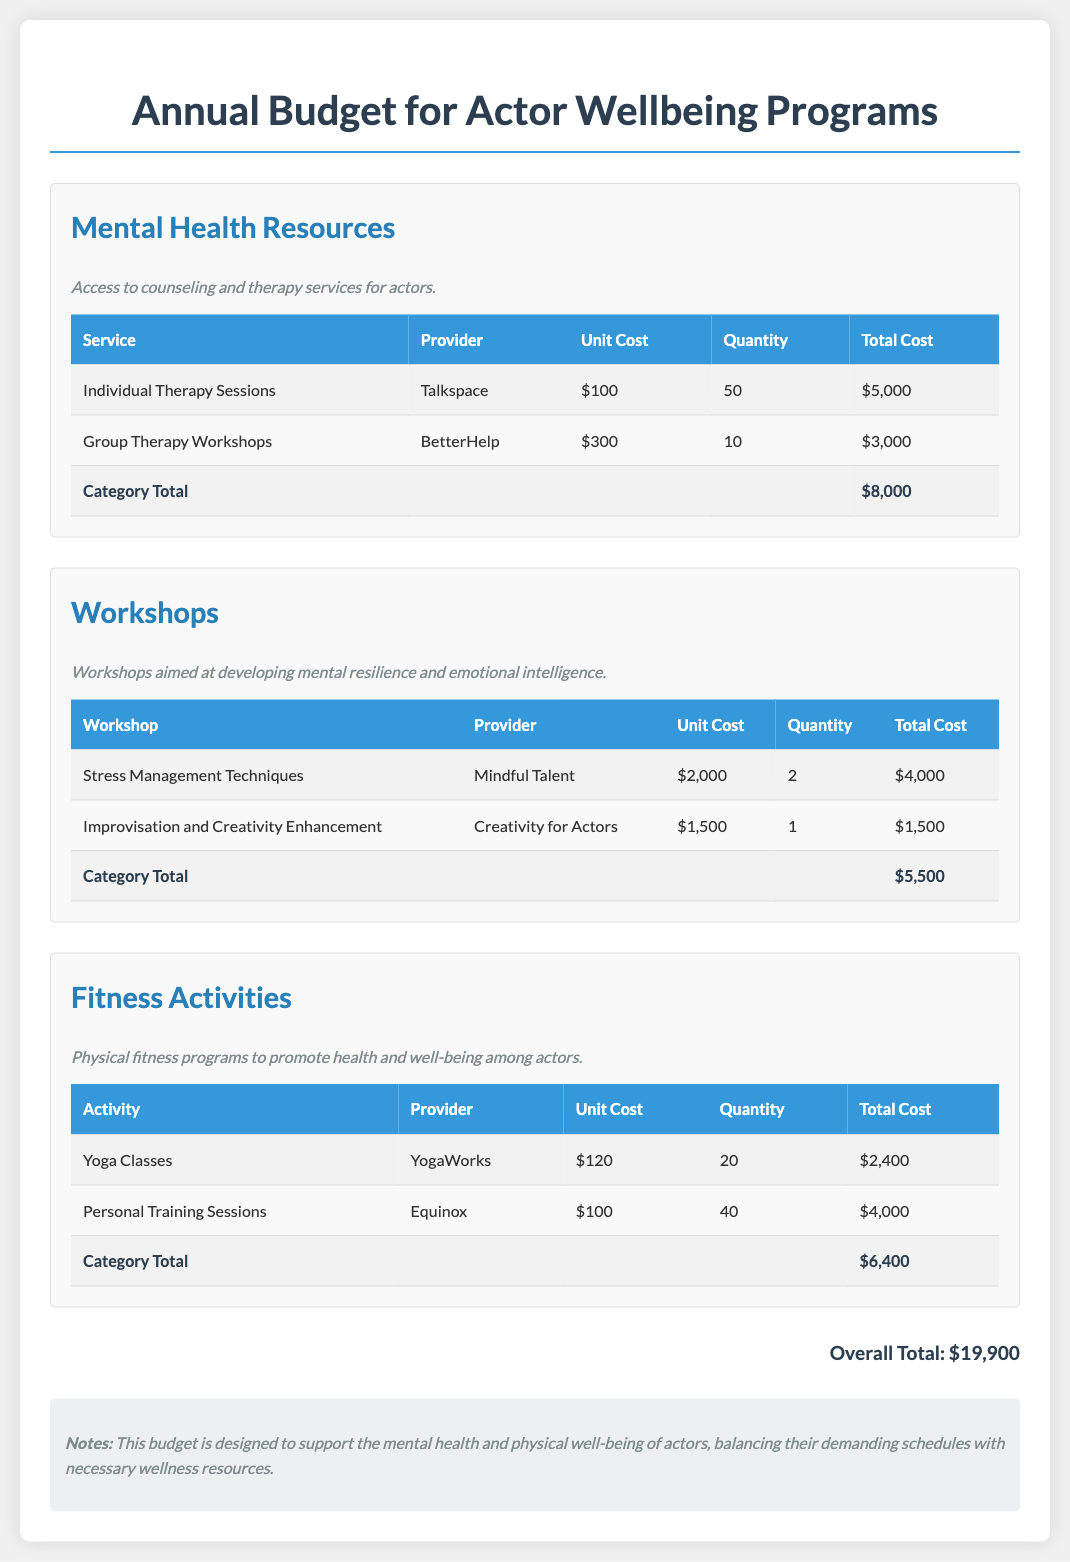What is the budget for individual therapy sessions? The budget for individual therapy sessions is listed as $5,000 in the Mental Health Resources section.
Answer: $5,000 How many group therapy workshops are planned? The document indicates that 10 group therapy workshops are planned under Mental Health Resources.
Answer: 10 What is the total cost for fitness activities? The total cost for fitness activities, as outlined in the Fitness Activities section, is $6,400.
Answer: $6,400 Who provides the stress management workshops? The stress management workshops are provided by Mindful Talent.
Answer: Mindful Talent What is the total annual budget for actor wellbeing programs? The overall total budget for actor wellbeing programs, calculated from all categories, is $19,900.
Answer: $19,900 How many yoga classes are included in the budget? The budget includes 20 yoga classes in the Fitness Activities section.
Answer: 20 Which provider offers the personal training sessions? The provider for personal training sessions is Equinox.
Answer: Equinox What is the unit cost of improvisation workshops? The unit cost for improvisation and creativity enhancement workshops is $1,500.
Answer: $1,500 What category has the highest total cost? The category with the highest total cost is Mental Health Resources, totaling $8,000.
Answer: Mental Health Resources 